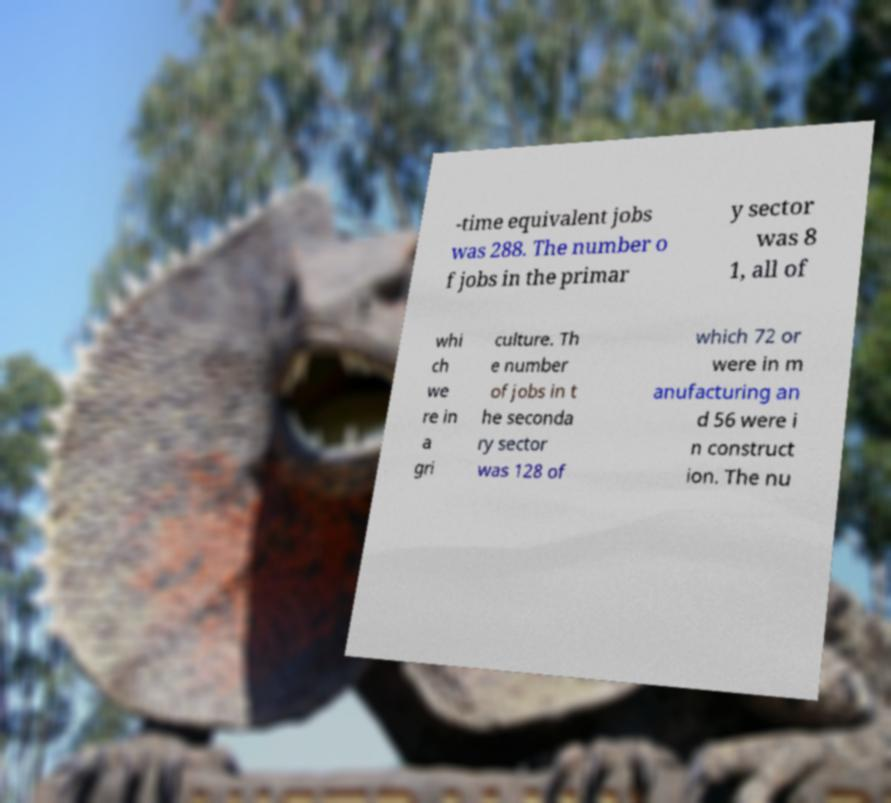I need the written content from this picture converted into text. Can you do that? -time equivalent jobs was 288. The number o f jobs in the primar y sector was 8 1, all of whi ch we re in a gri culture. Th e number of jobs in t he seconda ry sector was 128 of which 72 or were in m anufacturing an d 56 were i n construct ion. The nu 